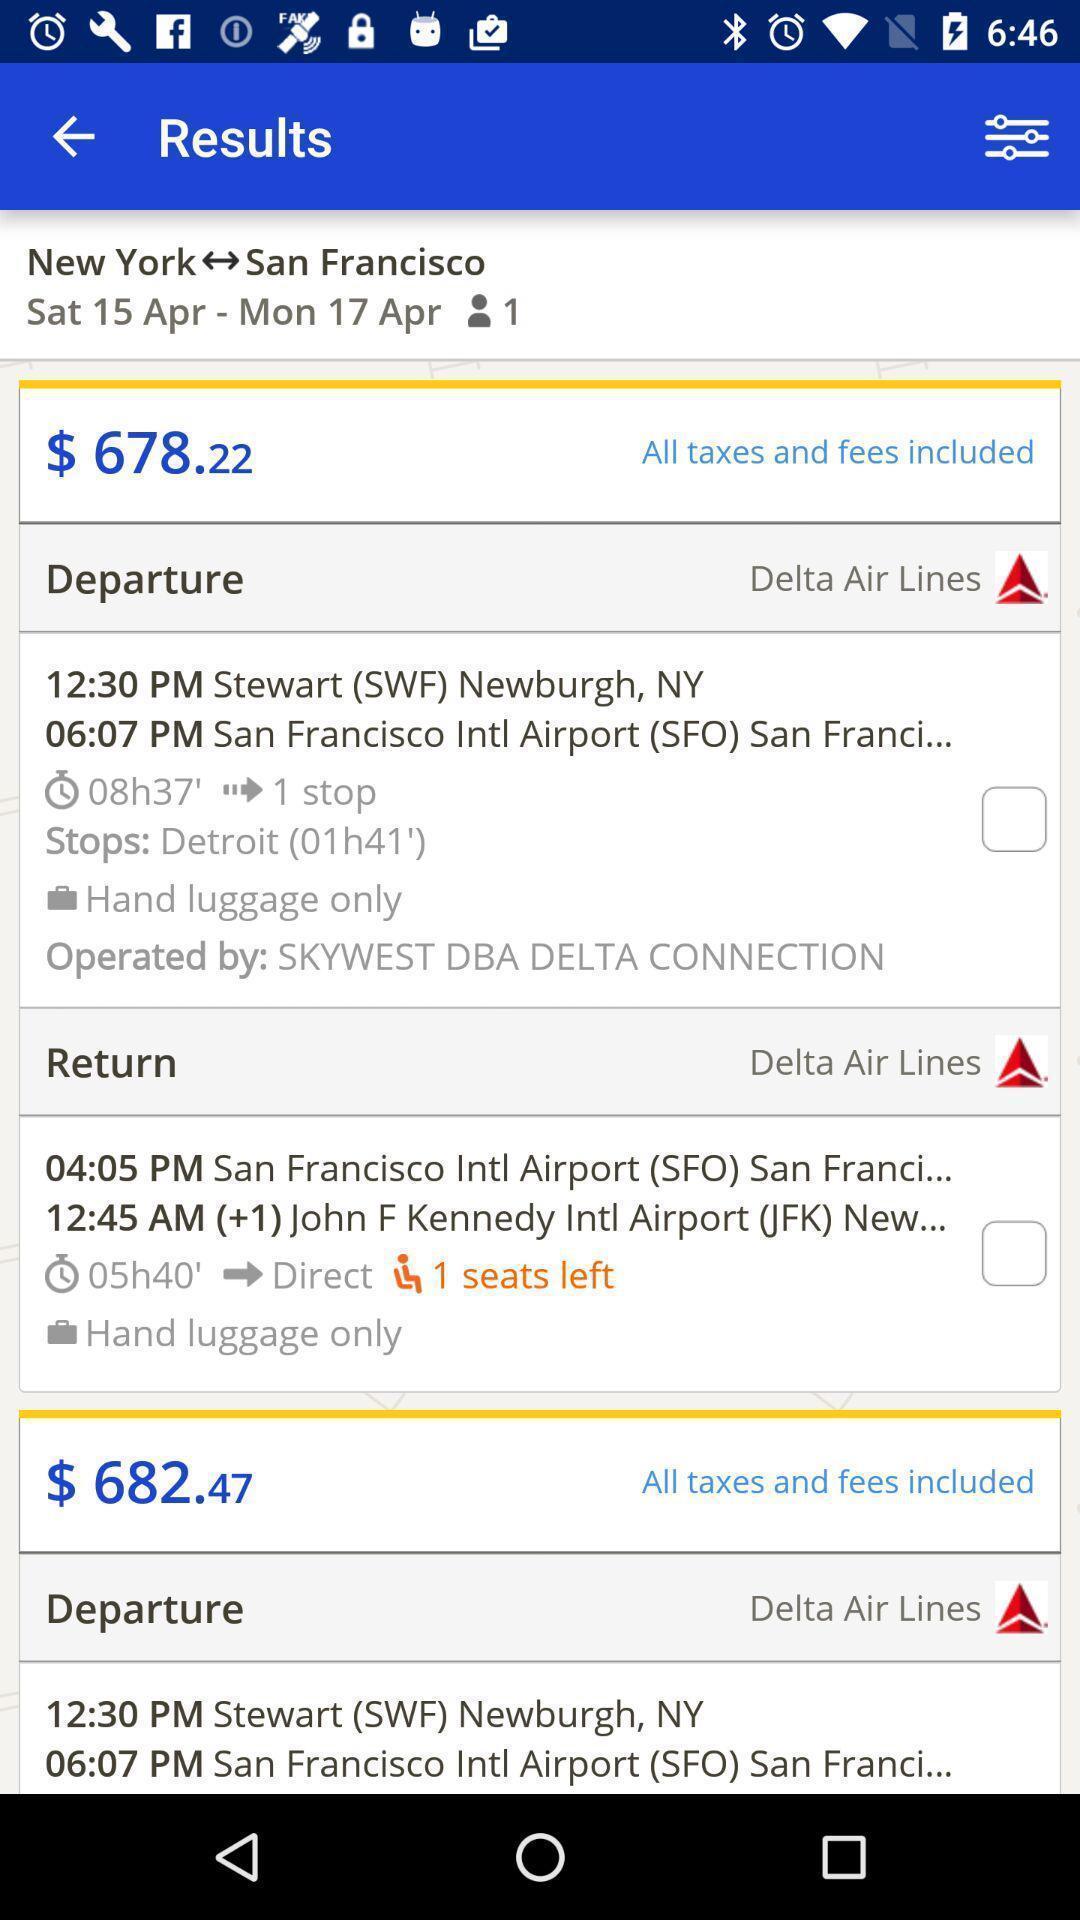Provide a detailed account of this screenshot. Page showing results in an travel application. 